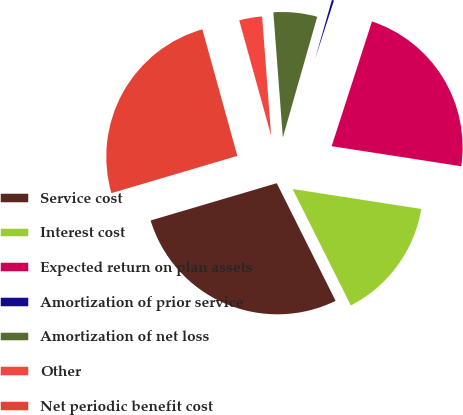Convert chart. <chart><loc_0><loc_0><loc_500><loc_500><pie_chart><fcel>Service cost<fcel>Interest cost<fcel>Expected return on plan assets<fcel>Amortization of prior service<fcel>Amortization of net loss<fcel>Other<fcel>Net periodic benefit cost<nl><fcel>27.81%<fcel>15.17%<fcel>22.47%<fcel>0.56%<fcel>5.62%<fcel>3.09%<fcel>25.28%<nl></chart> 